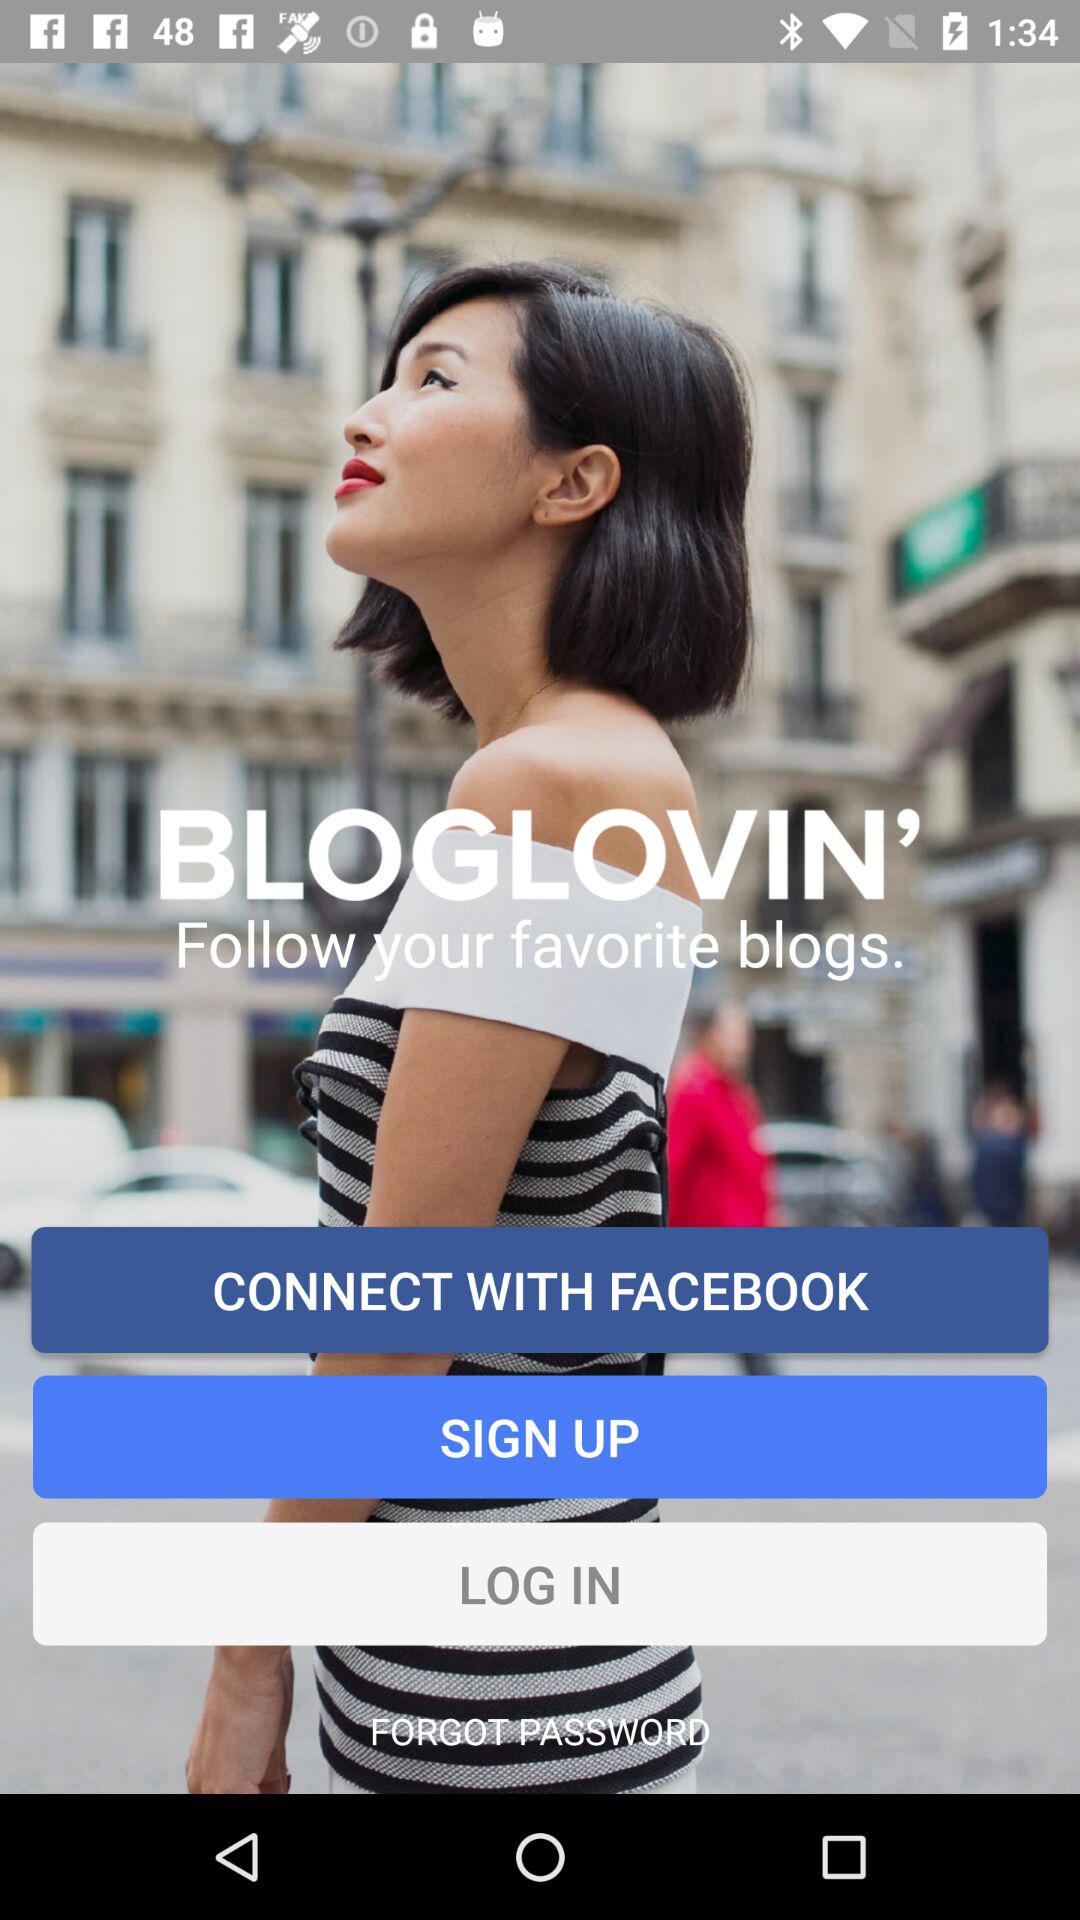Can you describe the design elements visible in the advertisement shown in the image? The advertisement in the image features a minimalist and modern design, emphasizing clean lines and a simple color scheme focused on various shades of blue. The text is bold and easily readable, set against a backdrop of a blurred urban setting that helps the text and options stand out. The design effectively draws attention to the connectivity options and the branding 'BLOGLOVIN', aimed at encouraging users to follow their favorite blogs. 